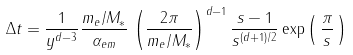<formula> <loc_0><loc_0><loc_500><loc_500>\Delta t = \frac { 1 } { y ^ { d - 3 } } \frac { m _ { e } / M _ { \ast } } { \alpha _ { e m } } \, \left ( \frac { 2 \pi } { m _ { e } / M _ { \ast } } \right ) ^ { d - 1 } \frac { s - 1 } { s ^ { ( d + 1 ) / 2 } } \exp \left ( \, \frac { \pi } { s } \, \right )</formula> 